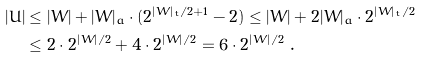<formula> <loc_0><loc_0><loc_500><loc_500>| U | & \leq | W | + | W | _ { a } \cdot ( 2 ^ { | W | _ { t } / 2 + 1 } - 2 ) \leq | W | + 2 | W | _ { a } \cdot 2 ^ { | W | _ { t } / 2 } \\ & \leq 2 \cdot 2 ^ { | W | / 2 } + 4 \cdot 2 ^ { | W | / 2 } = 6 \cdot 2 ^ { | W | / 2 } \ .</formula> 